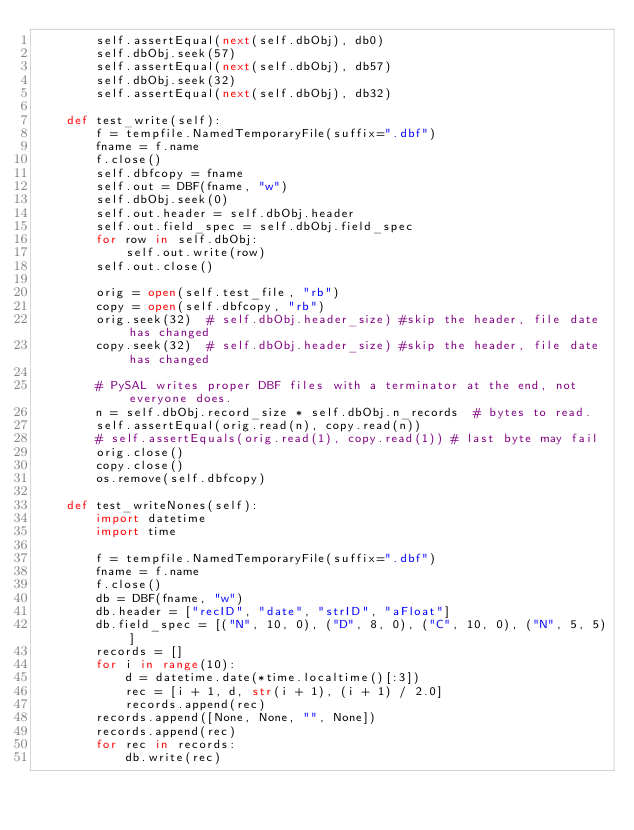Convert code to text. <code><loc_0><loc_0><loc_500><loc_500><_Python_>        self.assertEqual(next(self.dbObj), db0)
        self.dbObj.seek(57)
        self.assertEqual(next(self.dbObj), db57)
        self.dbObj.seek(32)
        self.assertEqual(next(self.dbObj), db32)

    def test_write(self):
        f = tempfile.NamedTemporaryFile(suffix=".dbf")
        fname = f.name
        f.close()
        self.dbfcopy = fname
        self.out = DBF(fname, "w")
        self.dbObj.seek(0)
        self.out.header = self.dbObj.header
        self.out.field_spec = self.dbObj.field_spec
        for row in self.dbObj:
            self.out.write(row)
        self.out.close()

        orig = open(self.test_file, "rb")
        copy = open(self.dbfcopy, "rb")
        orig.seek(32)  # self.dbObj.header_size) #skip the header, file date has changed
        copy.seek(32)  # self.dbObj.header_size) #skip the header, file date has changed

        # PySAL writes proper DBF files with a terminator at the end, not everyone does.
        n = self.dbObj.record_size * self.dbObj.n_records  # bytes to read.
        self.assertEqual(orig.read(n), copy.read(n))
        # self.assertEquals(orig.read(1), copy.read(1)) # last byte may fail
        orig.close()
        copy.close()
        os.remove(self.dbfcopy)

    def test_writeNones(self):
        import datetime
        import time

        f = tempfile.NamedTemporaryFile(suffix=".dbf")
        fname = f.name
        f.close()
        db = DBF(fname, "w")
        db.header = ["recID", "date", "strID", "aFloat"]
        db.field_spec = [("N", 10, 0), ("D", 8, 0), ("C", 10, 0), ("N", 5, 5)]
        records = []
        for i in range(10):
            d = datetime.date(*time.localtime()[:3])
            rec = [i + 1, d, str(i + 1), (i + 1) / 2.0]
            records.append(rec)
        records.append([None, None, "", None])
        records.append(rec)
        for rec in records:
            db.write(rec)</code> 